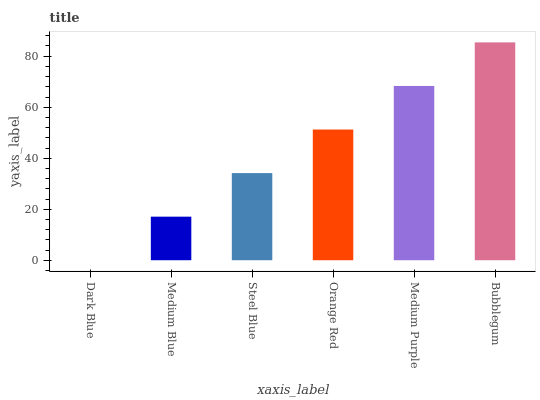Is Dark Blue the minimum?
Answer yes or no. Yes. Is Bubblegum the maximum?
Answer yes or no. Yes. Is Medium Blue the minimum?
Answer yes or no. No. Is Medium Blue the maximum?
Answer yes or no. No. Is Medium Blue greater than Dark Blue?
Answer yes or no. Yes. Is Dark Blue less than Medium Blue?
Answer yes or no. Yes. Is Dark Blue greater than Medium Blue?
Answer yes or no. No. Is Medium Blue less than Dark Blue?
Answer yes or no. No. Is Orange Red the high median?
Answer yes or no. Yes. Is Steel Blue the low median?
Answer yes or no. Yes. Is Steel Blue the high median?
Answer yes or no. No. Is Dark Blue the low median?
Answer yes or no. No. 